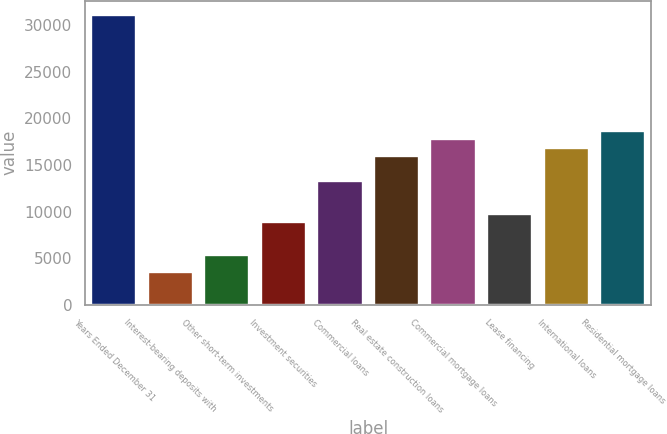<chart> <loc_0><loc_0><loc_500><loc_500><bar_chart><fcel>Years Ended December 31<fcel>Interest-bearing deposits with<fcel>Other short-term investments<fcel>Investment securities<fcel>Commercial loans<fcel>Real estate construction loans<fcel>Commercial mortgage loans<fcel>Lease financing<fcel>International loans<fcel>Residential mortgage loans<nl><fcel>31066<fcel>3550.44<fcel>5325.64<fcel>8876.04<fcel>13314<fcel>15976.8<fcel>17752<fcel>9763.64<fcel>16864.4<fcel>18639.6<nl></chart> 